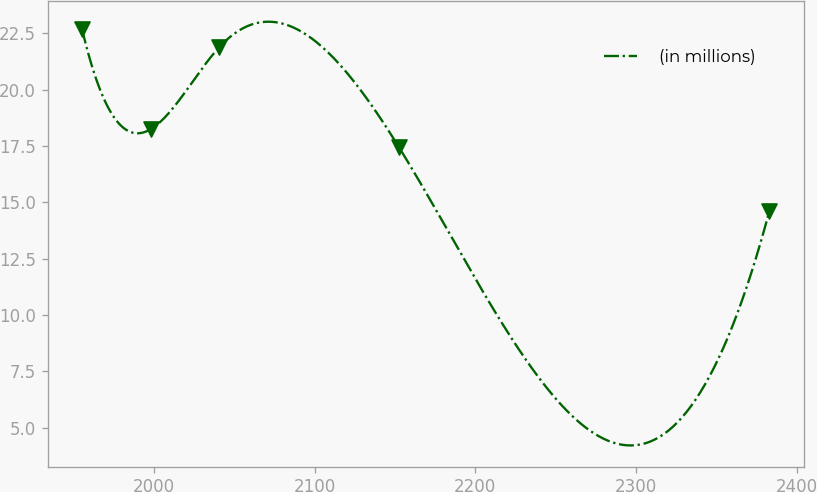Convert chart. <chart><loc_0><loc_0><loc_500><loc_500><line_chart><ecel><fcel>(in millions)<nl><fcel>1955.43<fcel>22.7<nl><fcel>1998.17<fcel>18.25<nl><fcel>2040.91<fcel>21.9<nl><fcel>2152.51<fcel>17.45<nl><fcel>2382.82<fcel>14.6<nl></chart> 